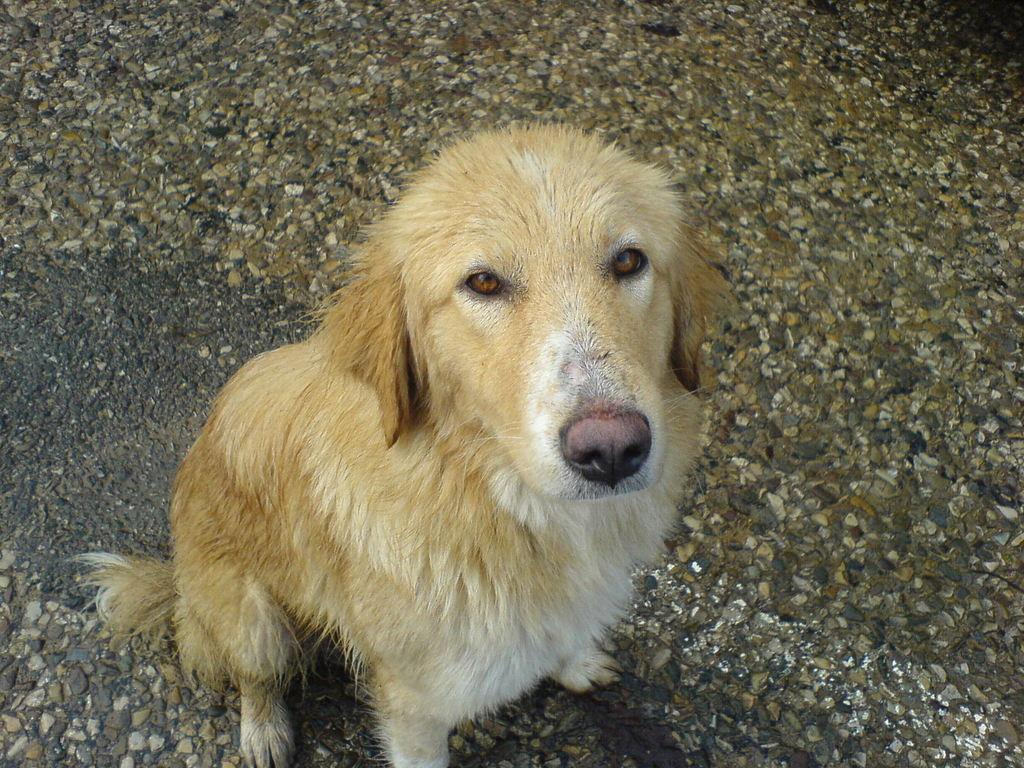What animal can be seen in the picture? There is a dog in the picture. What is the dog doing in the picture? The dog is looking at the camera. What can be seen at the bottom of the picture? There is a road visible at the bottom of the picture. Where is the goose in the picture? There is no goose present in the image. What is causing the dog to stop in the picture? The image does not show the dog stopping, and there is no information about a cause for the dog to stop. 